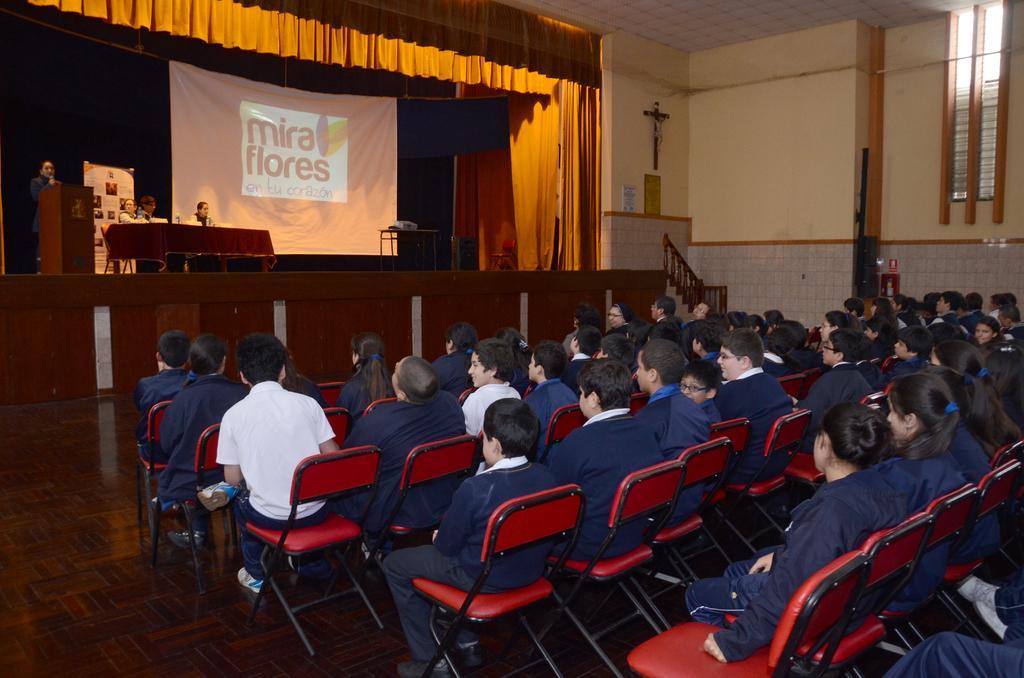Can you describe this image briefly? This image is taken indoors. At the bottom of the image there is a floor. In the background there is a wall and there are a few curtains. There is a dais and there is a table with a table cloth and a few things on it. There is a poster with a text on it and there is a projector screen. A few people are sitting on the chairs and a man is standing on the dais and there is a podium. On the right side of the image many children are sitting on the chairs. 